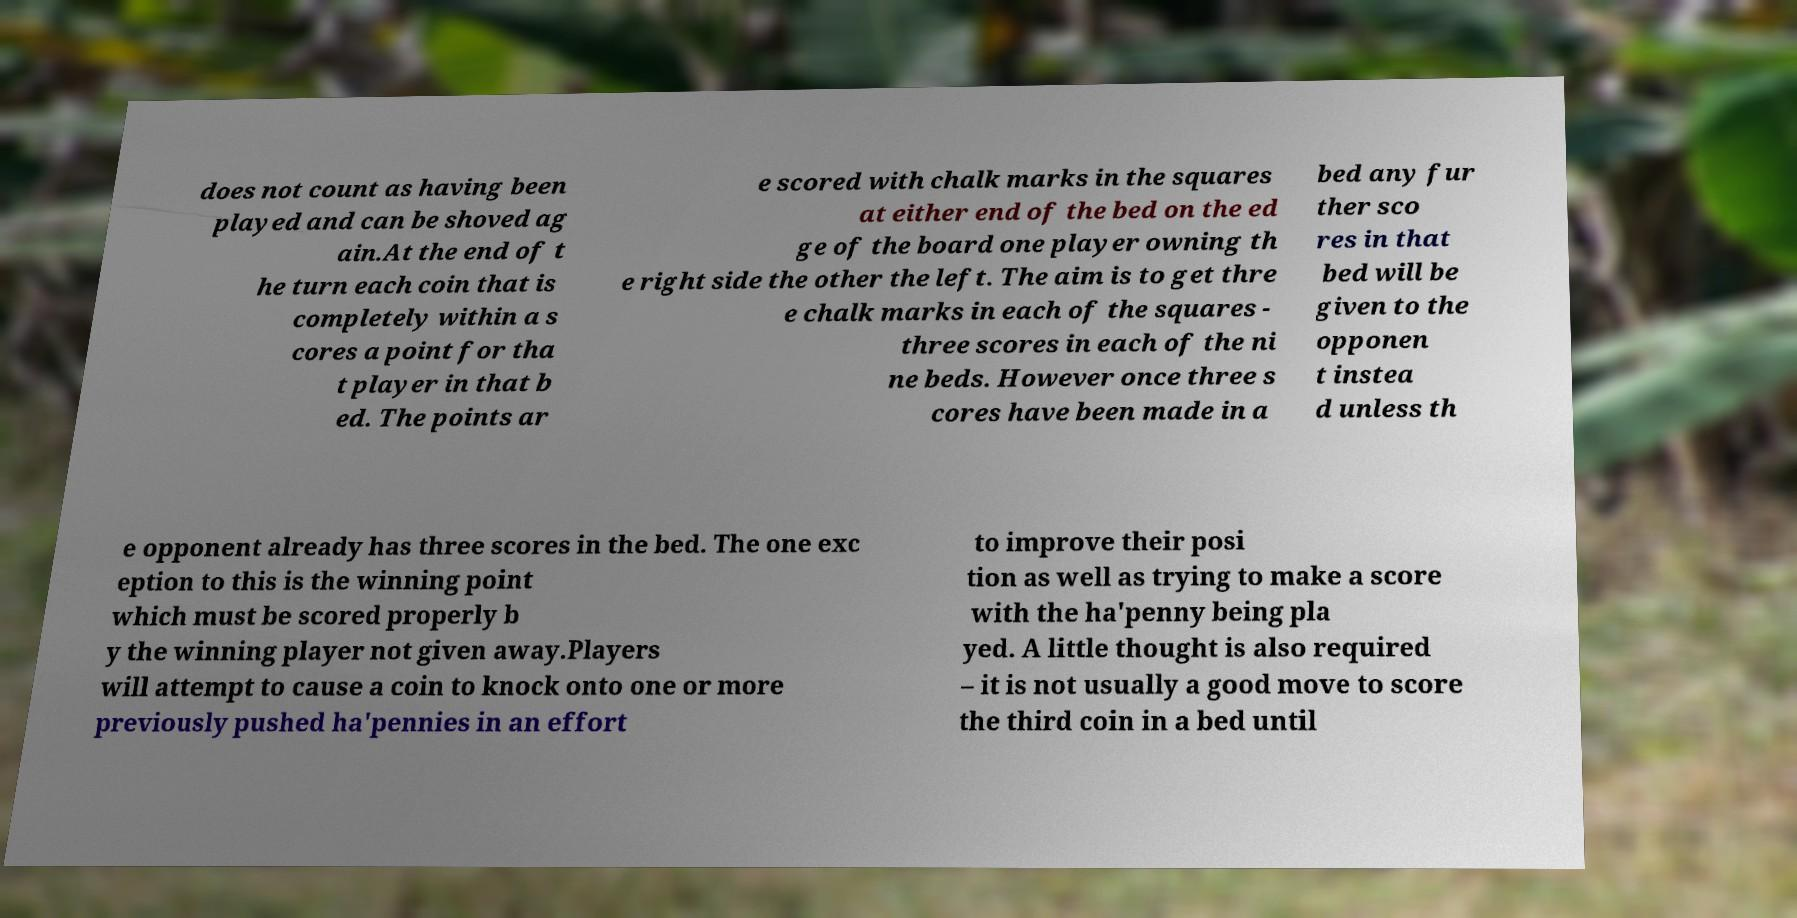For documentation purposes, I need the text within this image transcribed. Could you provide that? does not count as having been played and can be shoved ag ain.At the end of t he turn each coin that is completely within a s cores a point for tha t player in that b ed. The points ar e scored with chalk marks in the squares at either end of the bed on the ed ge of the board one player owning th e right side the other the left. The aim is to get thre e chalk marks in each of the squares - three scores in each of the ni ne beds. However once three s cores have been made in a bed any fur ther sco res in that bed will be given to the opponen t instea d unless th e opponent already has three scores in the bed. The one exc eption to this is the winning point which must be scored properly b y the winning player not given away.Players will attempt to cause a coin to knock onto one or more previously pushed ha'pennies in an effort to improve their posi tion as well as trying to make a score with the ha'penny being pla yed. A little thought is also required – it is not usually a good move to score the third coin in a bed until 